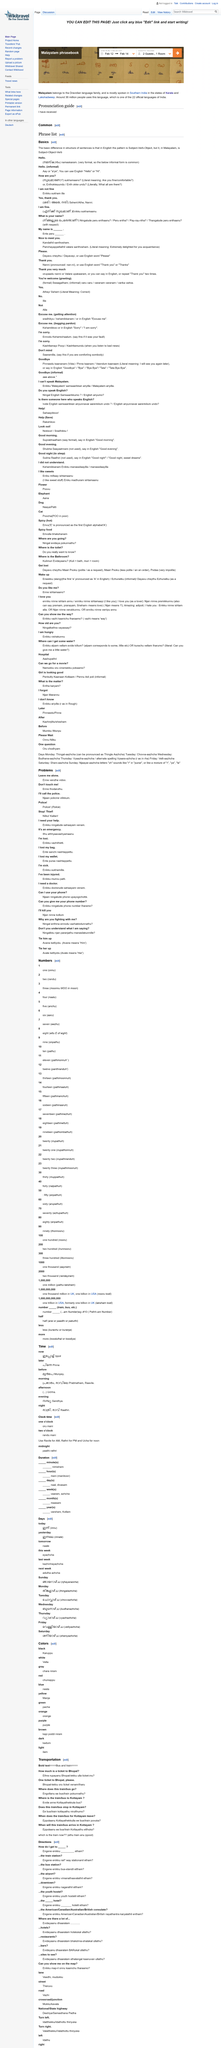Point out several critical features in this image. When will the train/bus arriving in Kottayam be translated as "Eppolaanu ee bus/train Kottayathu etthuka" in English. The phrase 'Nilku! Kallan!' translates to 'stop! Thief!' I do not like you. I am hungry" is the translation of the phrase "enikku vishakunnu" when translated into English. Please provide the translation of one ticket to Bhopal. The translation is Bhopal-lekku oru ticket venam/tharu... 